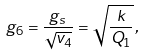Convert formula to latex. <formula><loc_0><loc_0><loc_500><loc_500>g _ { 6 } = \frac { g _ { s } } { \sqrt { v _ { 4 } } } = \sqrt { \frac { k } { Q _ { 1 } } } \, ,</formula> 